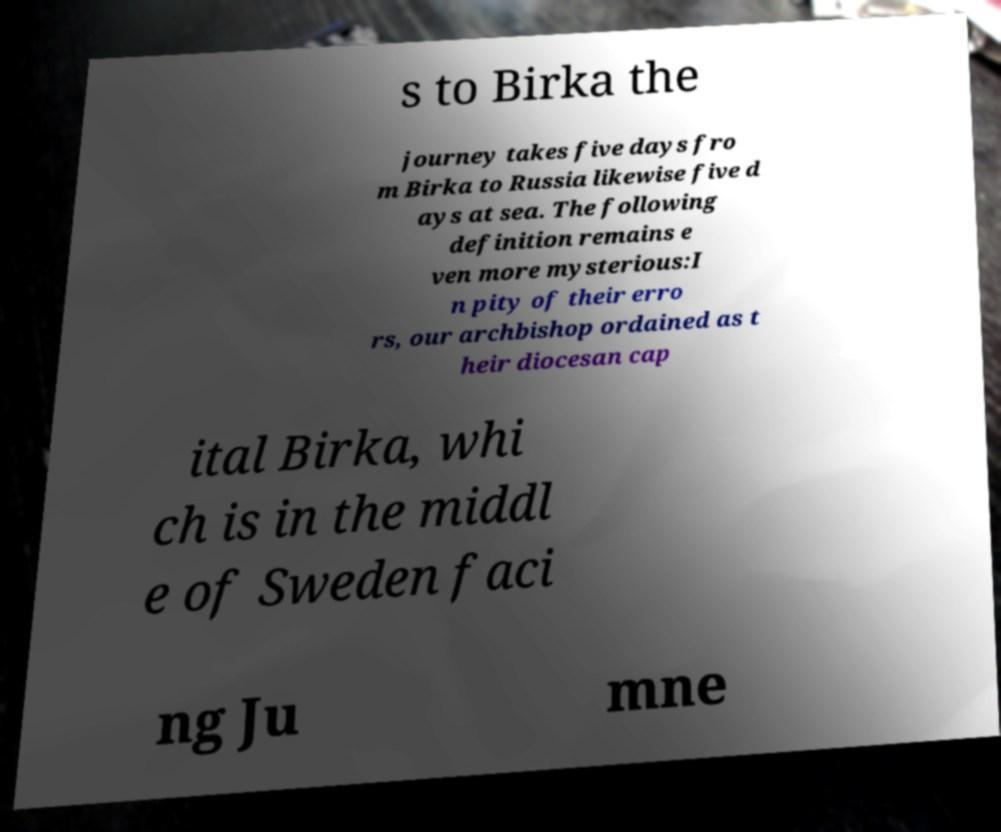For documentation purposes, I need the text within this image transcribed. Could you provide that? s to Birka the journey takes five days fro m Birka to Russia likewise five d ays at sea. The following definition remains e ven more mysterious:I n pity of their erro rs, our archbishop ordained as t heir diocesan cap ital Birka, whi ch is in the middl e of Sweden faci ng Ju mne 